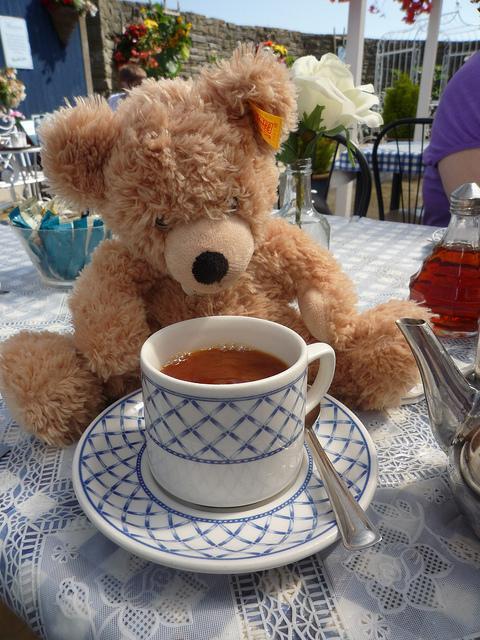Does the caption "The teddy bear is facing the person." correctly depict the image?
Answer yes or no. No. 